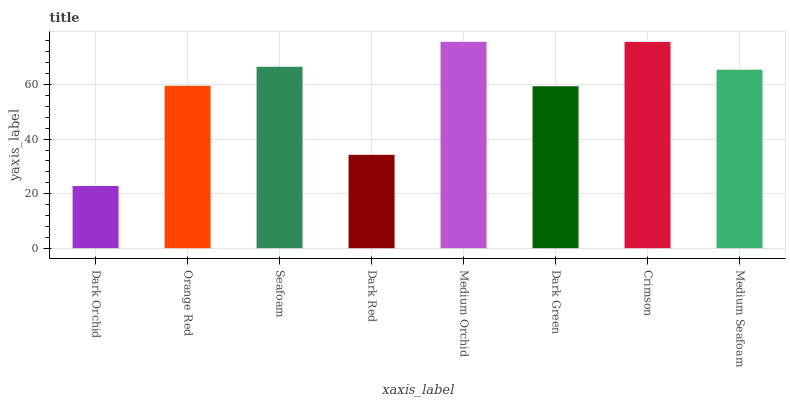Is Dark Orchid the minimum?
Answer yes or no. Yes. Is Medium Orchid the maximum?
Answer yes or no. Yes. Is Orange Red the minimum?
Answer yes or no. No. Is Orange Red the maximum?
Answer yes or no. No. Is Orange Red greater than Dark Orchid?
Answer yes or no. Yes. Is Dark Orchid less than Orange Red?
Answer yes or no. Yes. Is Dark Orchid greater than Orange Red?
Answer yes or no. No. Is Orange Red less than Dark Orchid?
Answer yes or no. No. Is Medium Seafoam the high median?
Answer yes or no. Yes. Is Orange Red the low median?
Answer yes or no. Yes. Is Seafoam the high median?
Answer yes or no. No. Is Dark Green the low median?
Answer yes or no. No. 